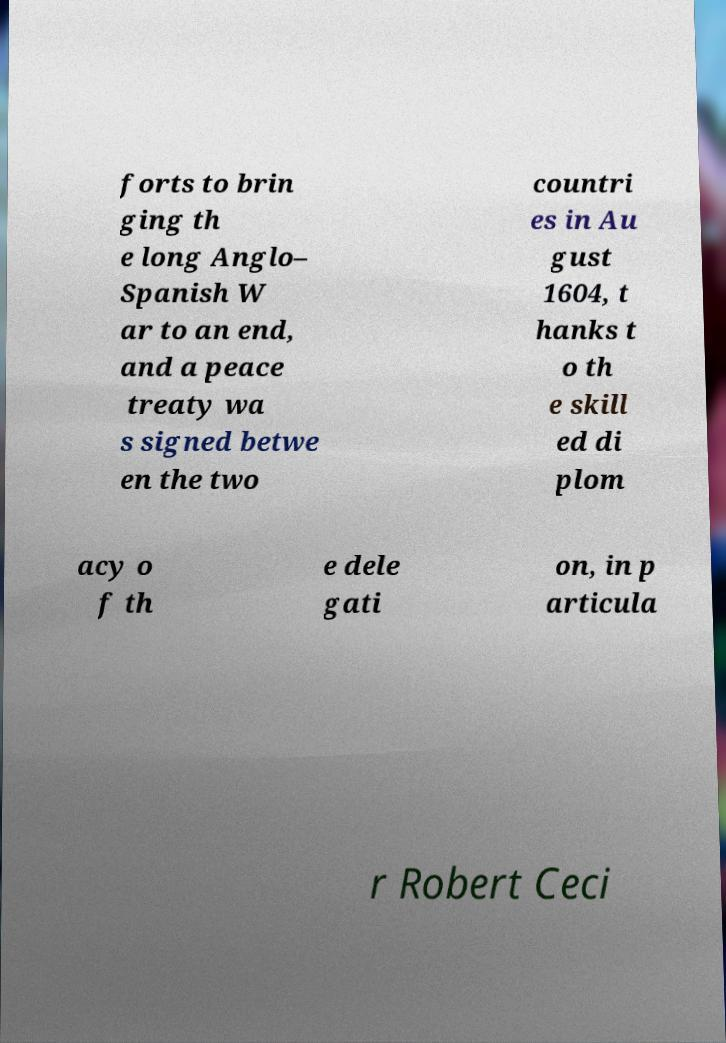Could you assist in decoding the text presented in this image and type it out clearly? forts to brin ging th e long Anglo– Spanish W ar to an end, and a peace treaty wa s signed betwe en the two countri es in Au gust 1604, t hanks t o th e skill ed di plom acy o f th e dele gati on, in p articula r Robert Ceci 